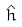<formula> <loc_0><loc_0><loc_500><loc_500>\hat { h }</formula> 